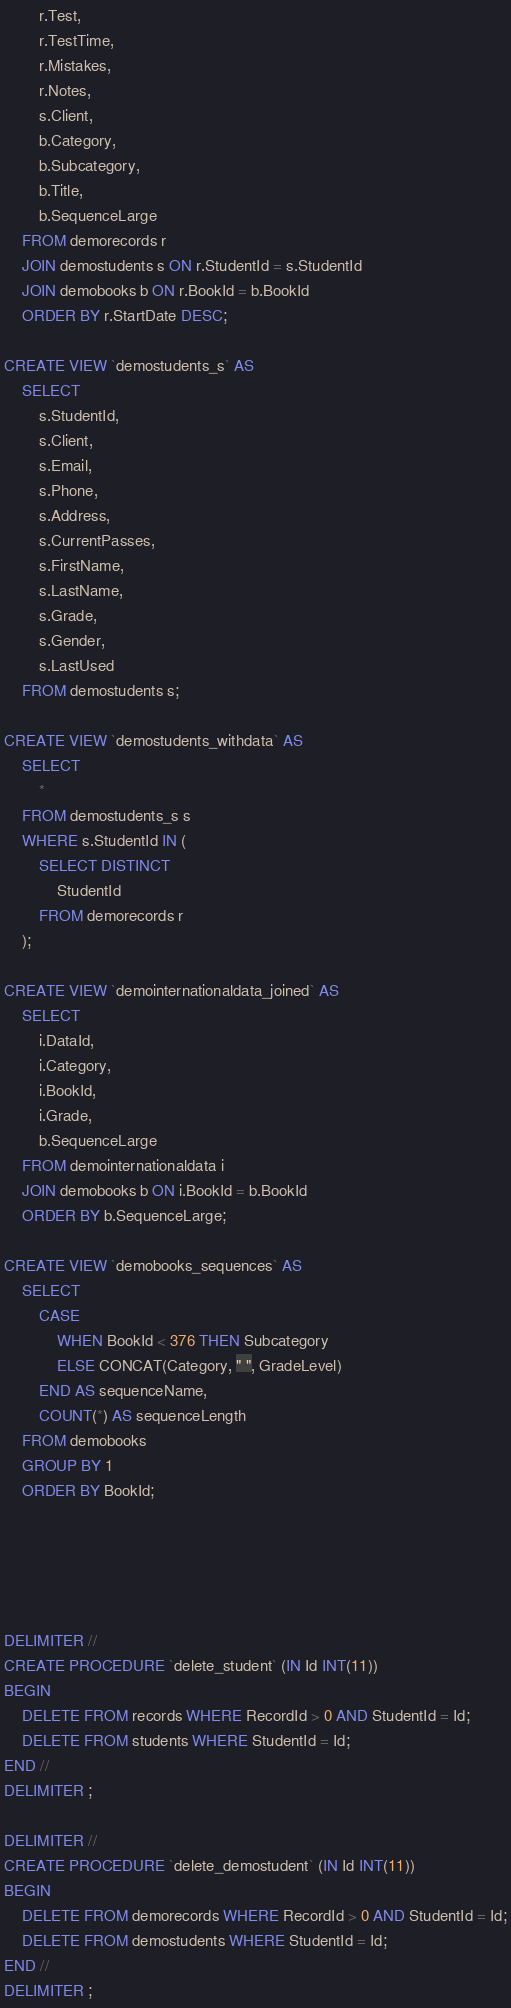<code> <loc_0><loc_0><loc_500><loc_500><_SQL_>        r.Test,
        r.TestTime,
        r.Mistakes,
        r.Notes,
        s.Client,
        b.Category,
        b.Subcategory,
        b.Title,
        b.SequenceLarge
    FROM demorecords r
	JOIN demostudents s ON r.StudentId = s.StudentId
	JOIN demobooks b ON r.BookId = b.BookId
	ORDER BY r.StartDate DESC;

CREATE VIEW `demostudents_s` AS
	SELECT
		s.StudentId,
        s.Client,
        s.Email,
        s.Phone,
        s.Address,
        s.CurrentPasses,
        s.FirstName,
        s.LastName,
        s.Grade,
        s.Gender,
        s.LastUsed
	FROM demostudents s;

CREATE VIEW `demostudents_withdata` AS
	SELECT
		*
	FROM demostudents_s s
    WHERE s.StudentId IN (
		SELECT DISTINCT
			StudentId
		FROM demorecords r
    );
    
CREATE VIEW `demointernationaldata_joined` AS
	SELECT
		i.DataId,
        i.Category, 
        i.BookId,
        i.Grade,
        b.SequenceLarge
	FROM demointernationaldata i
	JOIN demobooks b ON i.BookId = b.BookId
	ORDER BY b.SequenceLarge;
    
CREATE VIEW `demobooks_sequences` AS
	SELECT
		CASE
			WHEN BookId < 376 THEN Subcategory
			ELSE CONCAT(Category, " ", GradeLevel)
		END AS sequenceName,
		COUNT(*) AS sequenceLength
	FROM demobooks
	GROUP BY 1
	ORDER BY BookId;





DELIMITER //
CREATE PROCEDURE `delete_student` (IN Id INT(11))
BEGIN
	DELETE FROM records WHERE RecordId > 0 AND StudentId = Id;
	DELETE FROM students WHERE StudentId = Id;
END //
DELIMITER ;

DELIMITER //
CREATE PROCEDURE `delete_demostudent` (IN Id INT(11))
BEGIN
	DELETE FROM demorecords WHERE RecordId > 0 AND StudentId = Id;
	DELETE FROM demostudents WHERE StudentId = Id;
END //
DELIMITER ;</code> 